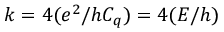<formula> <loc_0><loc_0><loc_500><loc_500>k = 4 ( e ^ { 2 } / h C _ { q } ) = 4 ( E / h )</formula> 